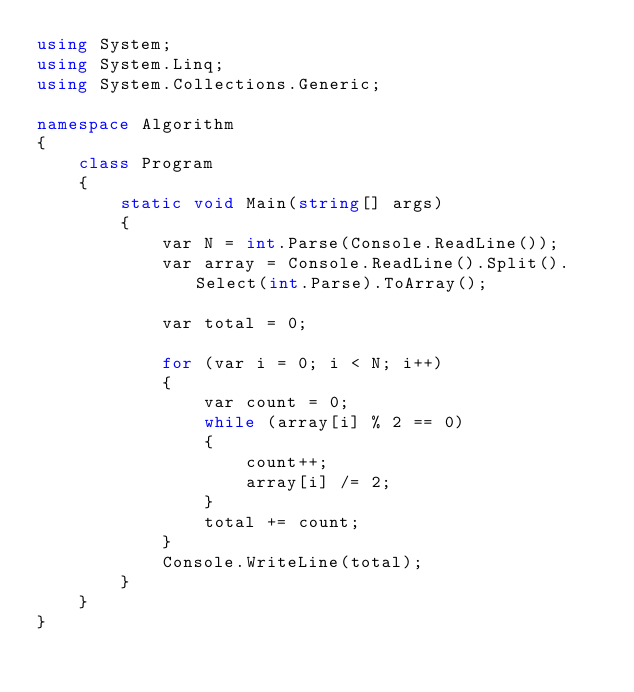Convert code to text. <code><loc_0><loc_0><loc_500><loc_500><_C#_>using System;
using System.Linq;
using System.Collections.Generic;

namespace Algorithm
{
    class Program
    {
        static void Main(string[] args)
        {
            var N = int.Parse(Console.ReadLine());
            var array = Console.ReadLine().Split().Select(int.Parse).ToArray();

            var total = 0;

            for (var i = 0; i < N; i++)
            {
                var count = 0;
                while (array[i] % 2 == 0)
                {
                    count++;
                    array[i] /= 2;
                }
                total += count;
            }
            Console.WriteLine(total);
        }
    }
}</code> 